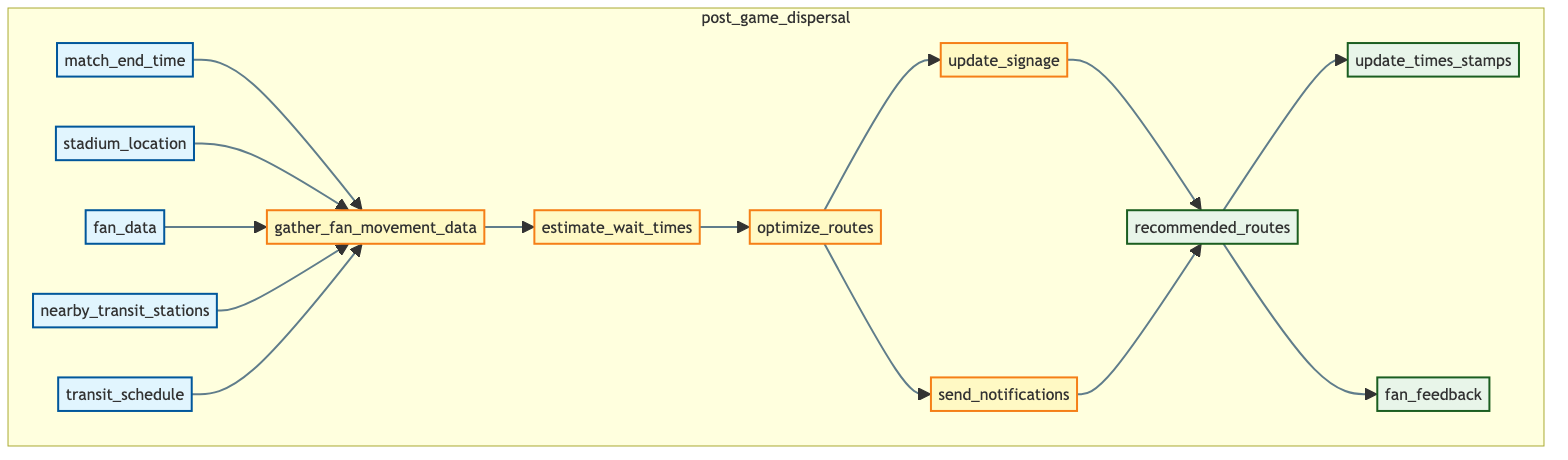What are the inputs of the function "post_game_dispersal"? The inputs listed in the diagram are match_end_time, stadium_location, fan_data, nearby_transit_stations, and transit_schedule. They all point to the first process, gathering fan movement data.
Answer: match_end_time, stadium_location, fan_data, nearby_transit_stations, transit_schedule How many processes are in the "post_game_dispersal" function? The diagram shows five processes: gather_fan_movement_data, estimate_wait_times, optimize_routes, update_signage, and send_notifications. Counting these, we find there are five processes.
Answer: 5 Which process comes directly after gathering fan movement data? The diagram indicates that after gathering fan movement data, the next process is estimate_wait_times, as connected by a direct arrow in the flowchart.
Answer: estimate_wait_times What outputs are produced by the function? The outputs produced are recommended_routes, update_times_stamps, and fan_feedback, which can be traced back from the final processes in the diagram.
Answer: recommended_routes, update_times_stamps, fan_feedback Which process sends notifications to fans' mobile devices? The process responsible for sending notifications is labeled as send_notifications in the diagram, which follows the optimize_routes process.
Answer: send_notifications What determines the best transit stations for fans to take? The best transit stations are determined through the optimize_routes process, which considers distance and wait times after estimating those wait times from the previous step.
Answer: optimize_routes How many distinct outputs are there in the diagram? The diagram indicates three distinct outputs that are generated after the processes are executed: recommended_routes, update_times_stamps, and fan_feedback. Thus, there are three outputs in total.
Answer: 3 Which process is responsible for updating signage? According to the flowchart, updating signage is the responsibility of the process labeled update_signage. It is the step that comes after optimizing the routes to transit stations.
Answer: update_signage Where does fan data flow into the function? Fan data flows into the function from the left side as one of the inputs, specifically entering into the first process, gathering fan movement data, along with the other inputs.
Answer: gathering_fan_movement_data 